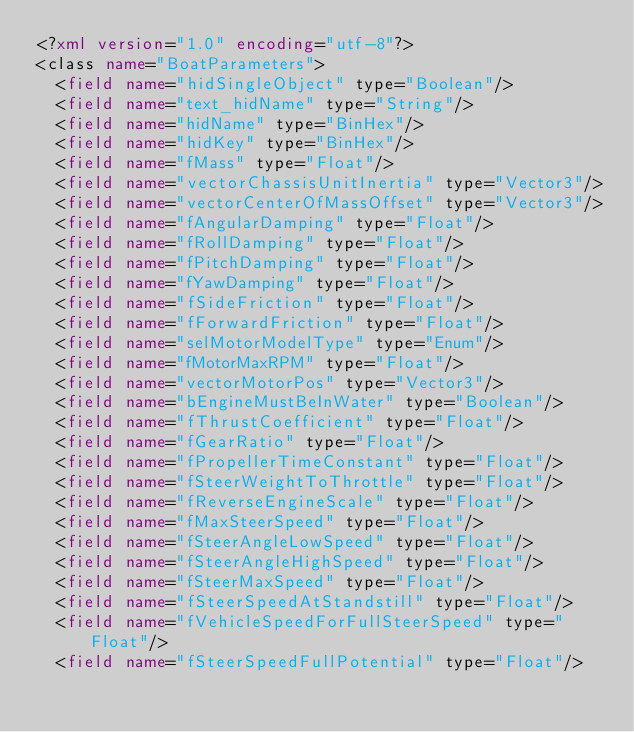<code> <loc_0><loc_0><loc_500><loc_500><_XML_><?xml version="1.0" encoding="utf-8"?>
<class name="BoatParameters">
	<field name="hidSingleObject" type="Boolean"/>
	<field name="text_hidName" type="String"/>
	<field name="hidName" type="BinHex"/>
	<field name="hidKey" type="BinHex"/>
	<field name="fMass" type="Float"/>
	<field name="vectorChassisUnitInertia" type="Vector3"/>
	<field name="vectorCenterOfMassOffset" type="Vector3"/>
	<field name="fAngularDamping" type="Float"/>
	<field name="fRollDamping" type="Float"/>
	<field name="fPitchDamping" type="Float"/>
	<field name="fYawDamping" type="Float"/>
	<field name="fSideFriction" type="Float"/>
	<field name="fForwardFriction" type="Float"/>
	<field name="selMotorModelType" type="Enum"/>
	<field name="fMotorMaxRPM" type="Float"/>
	<field name="vectorMotorPos" type="Vector3"/>
	<field name="bEngineMustBeInWater" type="Boolean"/>
	<field name="fThrustCoefficient" type="Float"/>
	<field name="fGearRatio" type="Float"/>
	<field name="fPropellerTimeConstant" type="Float"/>
	<field name="fSteerWeightToThrottle" type="Float"/>
	<field name="fReverseEngineScale" type="Float"/>
	<field name="fMaxSteerSpeed" type="Float"/>
	<field name="fSteerAngleLowSpeed" type="Float"/>
	<field name="fSteerAngleHighSpeed" type="Float"/>
	<field name="fSteerMaxSpeed" type="Float"/>
	<field name="fSteerSpeedAtStandstill" type="Float"/>
	<field name="fVehicleSpeedForFullSteerSpeed" type="Float"/>
	<field name="fSteerSpeedFullPotential" type="Float"/></code> 